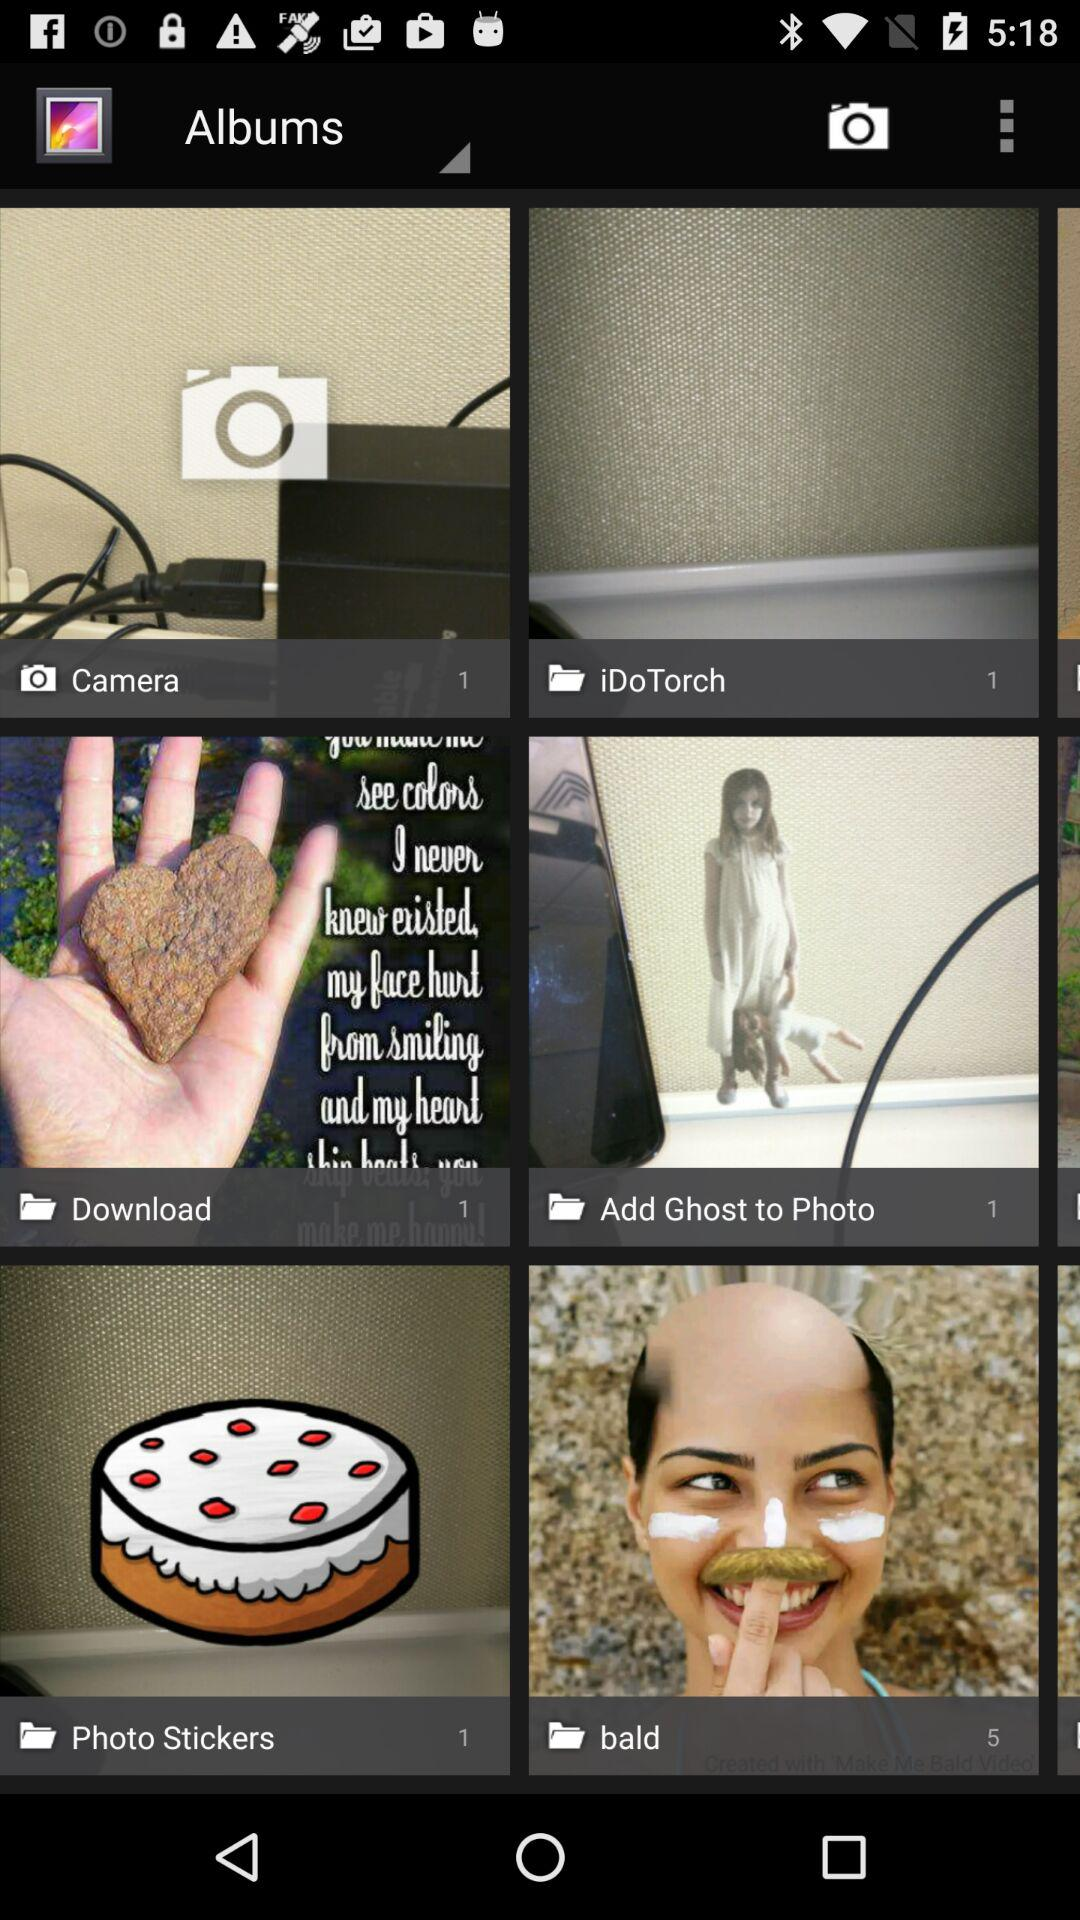When was the image uploaded to "Photo Stickers"?
When the provided information is insufficient, respond with <no answer>. <no answer> 